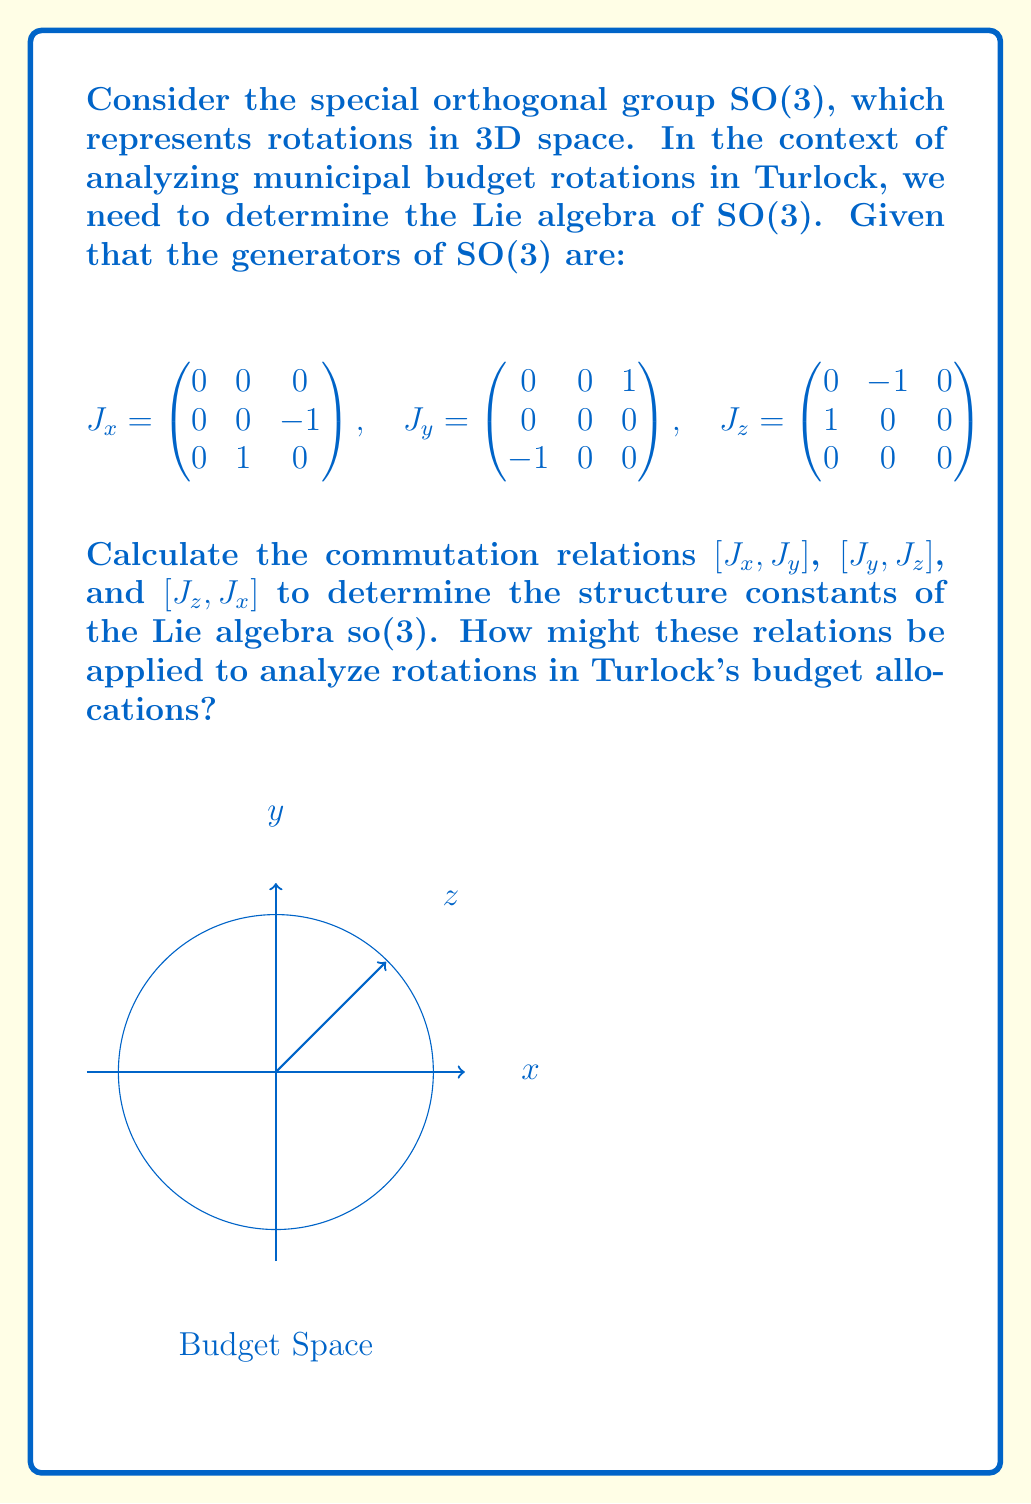Solve this math problem. To determine the Lie algebra of SO(3), we need to calculate the commutation relations between the generators:

1) First, let's calculate $[J_x, J_y]$:
   $$[J_x, J_y] = J_x J_y - J_y J_x = \begin{pmatrix}
   0 & 0 & 0 \\
   -1 & 0 & 0 \\
   0 & 0 & 0
   \end{pmatrix} - \begin{pmatrix}
   0 & 0 & 0 \\
   0 & 0 & -1 \\
   0 & 0 & 0
   \end{pmatrix} = J_z$$

2) Similarly, for $[J_y, J_z]$:
   $$[J_y, J_z] = J_y J_z - J_z J_y = \begin{pmatrix}
   0 & 0 & 0 \\
   0 & 0 & 1 \\
   0 & 0 & 0
   \end{pmatrix} - \begin{pmatrix}
   -1 & 0 & 0 \\
   0 & 0 & 0 \\
   0 & 0 & 0
   \end{pmatrix} = J_x$$

3) Lastly, for $[J_z, J_x]$:
   $$[J_z, J_x] = J_z J_x - J_x J_z = \begin{pmatrix}
   0 & 0 & 1 \\
   0 & 0 & 0 \\
   0 & 0 & 0
   \end{pmatrix} - \begin{pmatrix}
   0 & -1 & 0 \\
   0 & 0 & 0 \\
   0 & 0 & 0
   \end{pmatrix} = J_y$$

These commutation relations can be summarized as:
$$[J_i, J_j] = \epsilon_{ijk} J_k$$
where $\epsilon_{ijk}$ is the Levi-Civita symbol.

The structure constants of the Lie algebra so(3) are thus given by the Levi-Civita symbol $\epsilon_{ijk}$.

Application to Turlock's budget allocations:
1) The generators $J_x$, $J_y$, and $J_z$ can represent rotations of budget allocations in different sectors (e.g., infrastructure, education, public safety).
2) The commutation relations show how changes in one sector affect others, highlighting the interconnected nature of budget decisions.
3) The structure constants ($\epsilon_{ijk}$) quantify the magnitude and direction of these inter-sector effects, which could be used to predict the impact of budget reallocations.
4) This mathematical framework can help identify optimal budget rotation strategies that minimize negative impacts and maximize overall community benefit.
Answer: The Lie algebra of SO(3) is so(3) with commutation relations $[J_i, J_j] = \epsilon_{ijk} J_k$, where $\epsilon_{ijk}$ are the structure constants. 